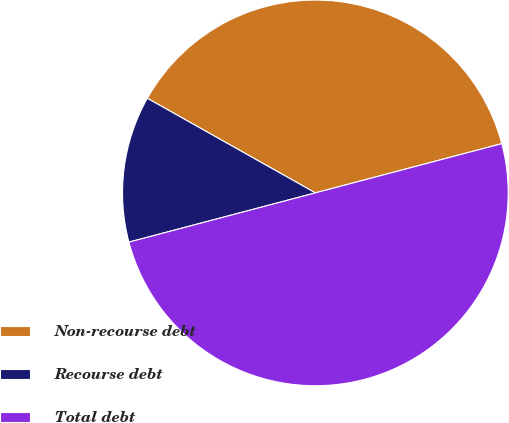Convert chart. <chart><loc_0><loc_0><loc_500><loc_500><pie_chart><fcel>Non-recourse debt<fcel>Recourse debt<fcel>Total debt<nl><fcel>37.73%<fcel>12.27%<fcel>50.0%<nl></chart> 